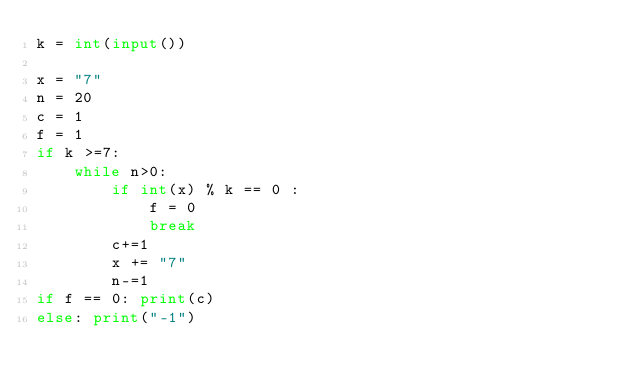<code> <loc_0><loc_0><loc_500><loc_500><_Python_>k = int(input())

x = "7"
n = 20
c = 1
f = 1
if k >=7:
    while n>0:
        if int(x) % k == 0 : 
            f = 0
            break
        c+=1
        x += "7"
        n-=1
if f == 0: print(c)
else: print("-1")</code> 